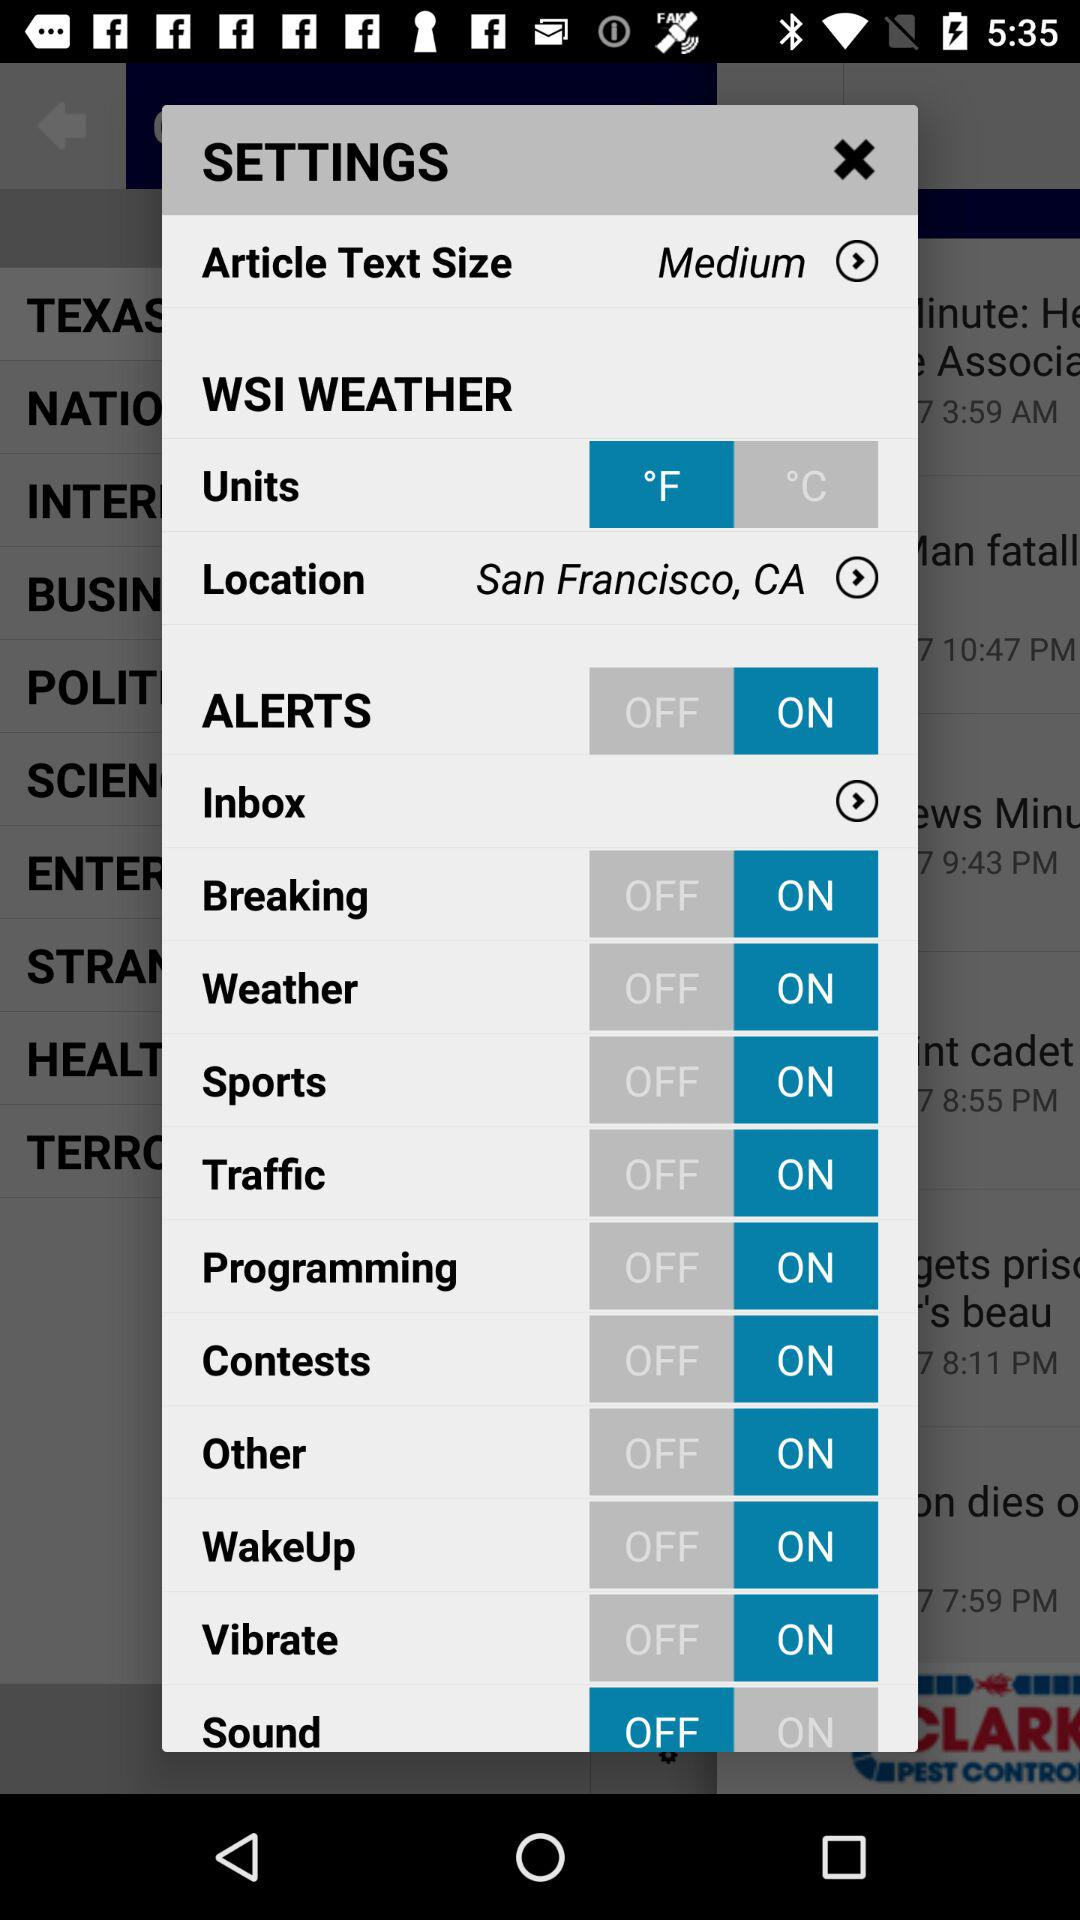What is the text size? The text size is medium. 